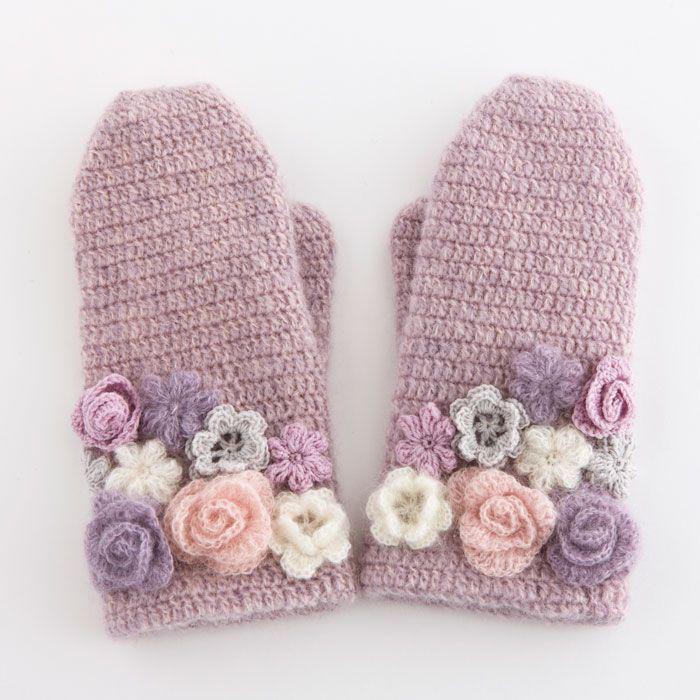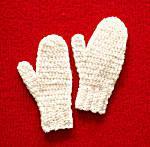The first image is the image on the left, the second image is the image on the right. Examine the images to the left and right. Is the description "The mittens in the image on the right have hands in them." accurate? Answer yes or no. No. 